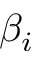<formula> <loc_0><loc_0><loc_500><loc_500>\beta _ { i }</formula> 